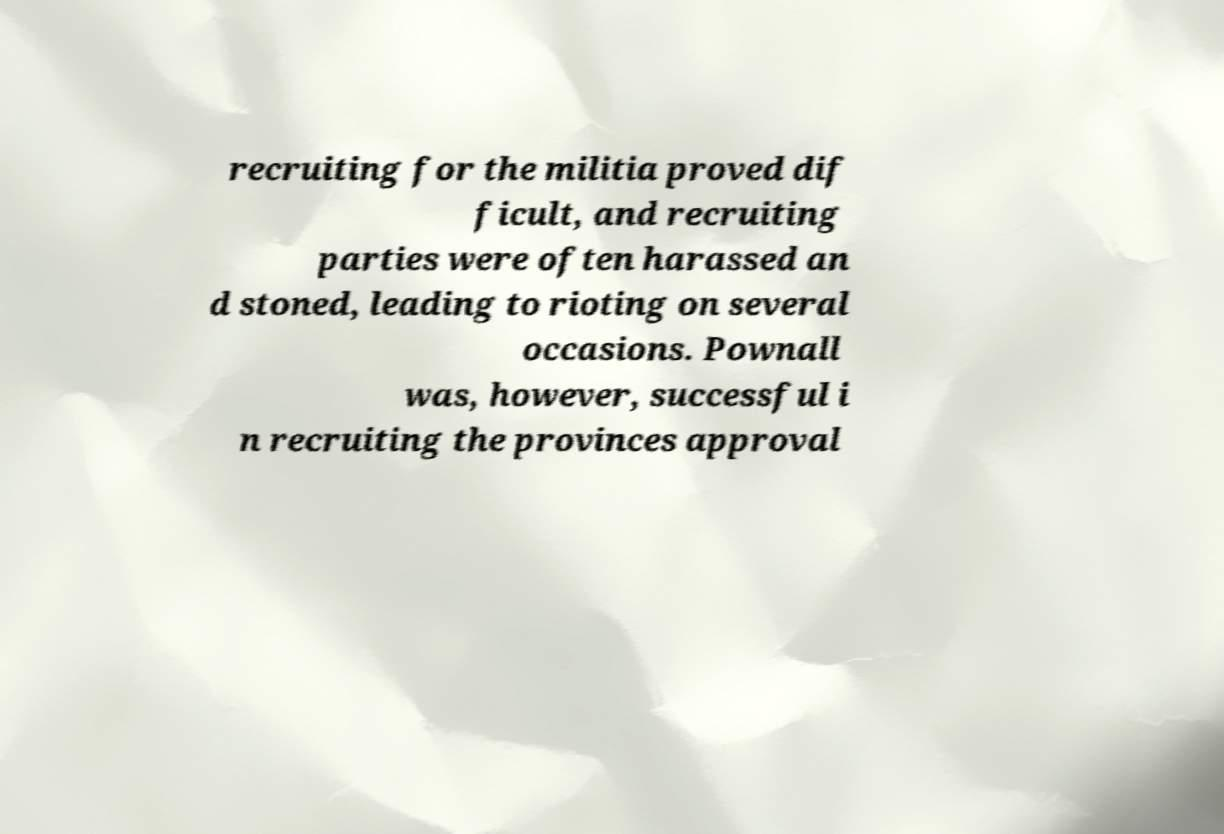Please read and relay the text visible in this image. What does it say? recruiting for the militia proved dif ficult, and recruiting parties were often harassed an d stoned, leading to rioting on several occasions. Pownall was, however, successful i n recruiting the provinces approval 